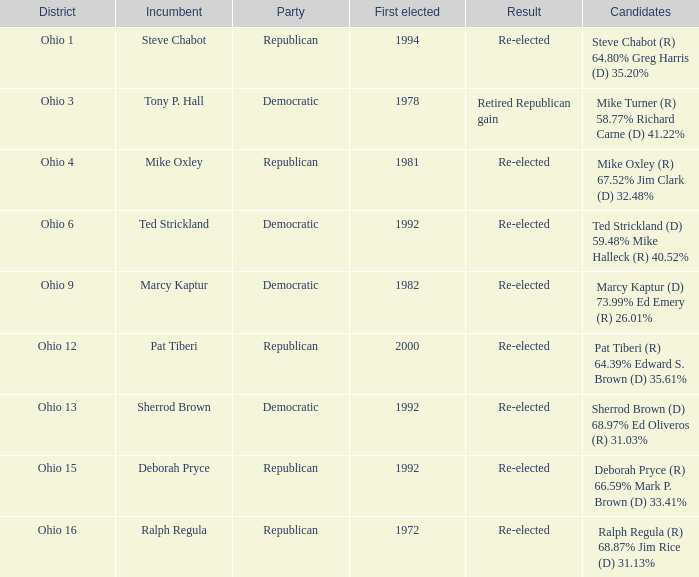Deborah pryce, as an incumbent, was part of which party? Republican. 